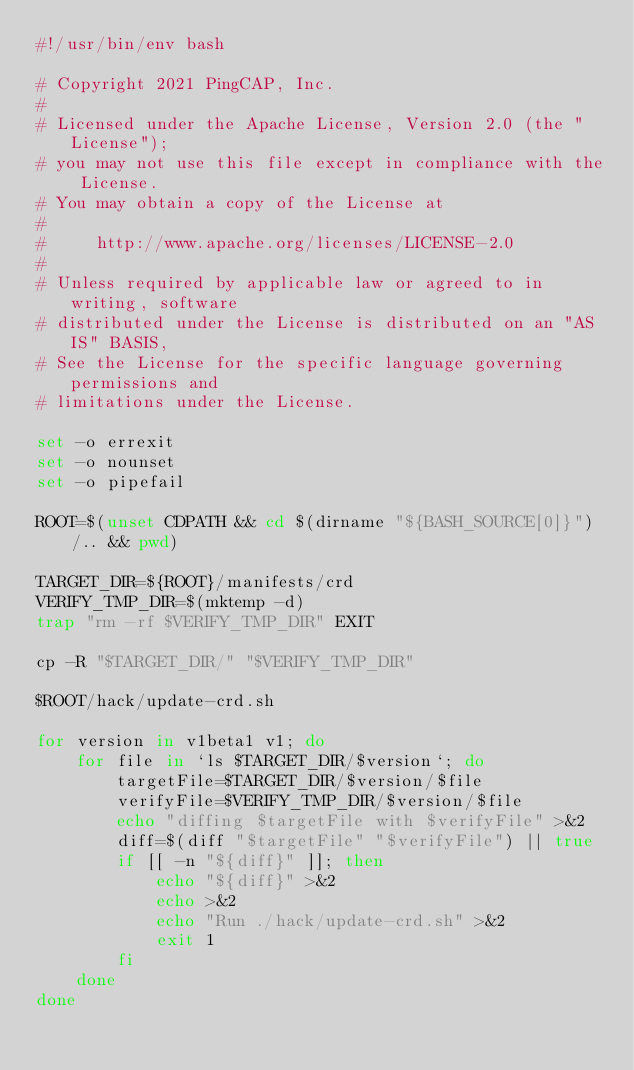<code> <loc_0><loc_0><loc_500><loc_500><_Bash_>#!/usr/bin/env bash

# Copyright 2021 PingCAP, Inc.
#
# Licensed under the Apache License, Version 2.0 (the "License");
# you may not use this file except in compliance with the License.
# You may obtain a copy of the License at
#
#     http://www.apache.org/licenses/LICENSE-2.0
#
# Unless required by applicable law or agreed to in writing, software
# distributed under the License is distributed on an "AS IS" BASIS,
# See the License for the specific language governing permissions and
# limitations under the License.

set -o errexit
set -o nounset
set -o pipefail

ROOT=$(unset CDPATH && cd $(dirname "${BASH_SOURCE[0]}")/.. && pwd)

TARGET_DIR=${ROOT}/manifests/crd
VERIFY_TMP_DIR=$(mktemp -d)
trap "rm -rf $VERIFY_TMP_DIR" EXIT

cp -R "$TARGET_DIR/" "$VERIFY_TMP_DIR"

$ROOT/hack/update-crd.sh

for version in v1beta1 v1; do
    for file in `ls $TARGET_DIR/$version`; do
        targetFile=$TARGET_DIR/$version/$file
        verifyFile=$VERIFY_TMP_DIR/$version/$file
        echo "diffing $targetFile with $verifyFile" >&2
        diff=$(diff "$targetFile" "$verifyFile") || true
        if [[ -n "${diff}" ]]; then
            echo "${diff}" >&2
            echo >&2
            echo "Run ./hack/update-crd.sh" >&2
            exit 1
        fi
    done
done
</code> 